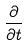<formula> <loc_0><loc_0><loc_500><loc_500>\frac { \partial } { \partial t }</formula> 